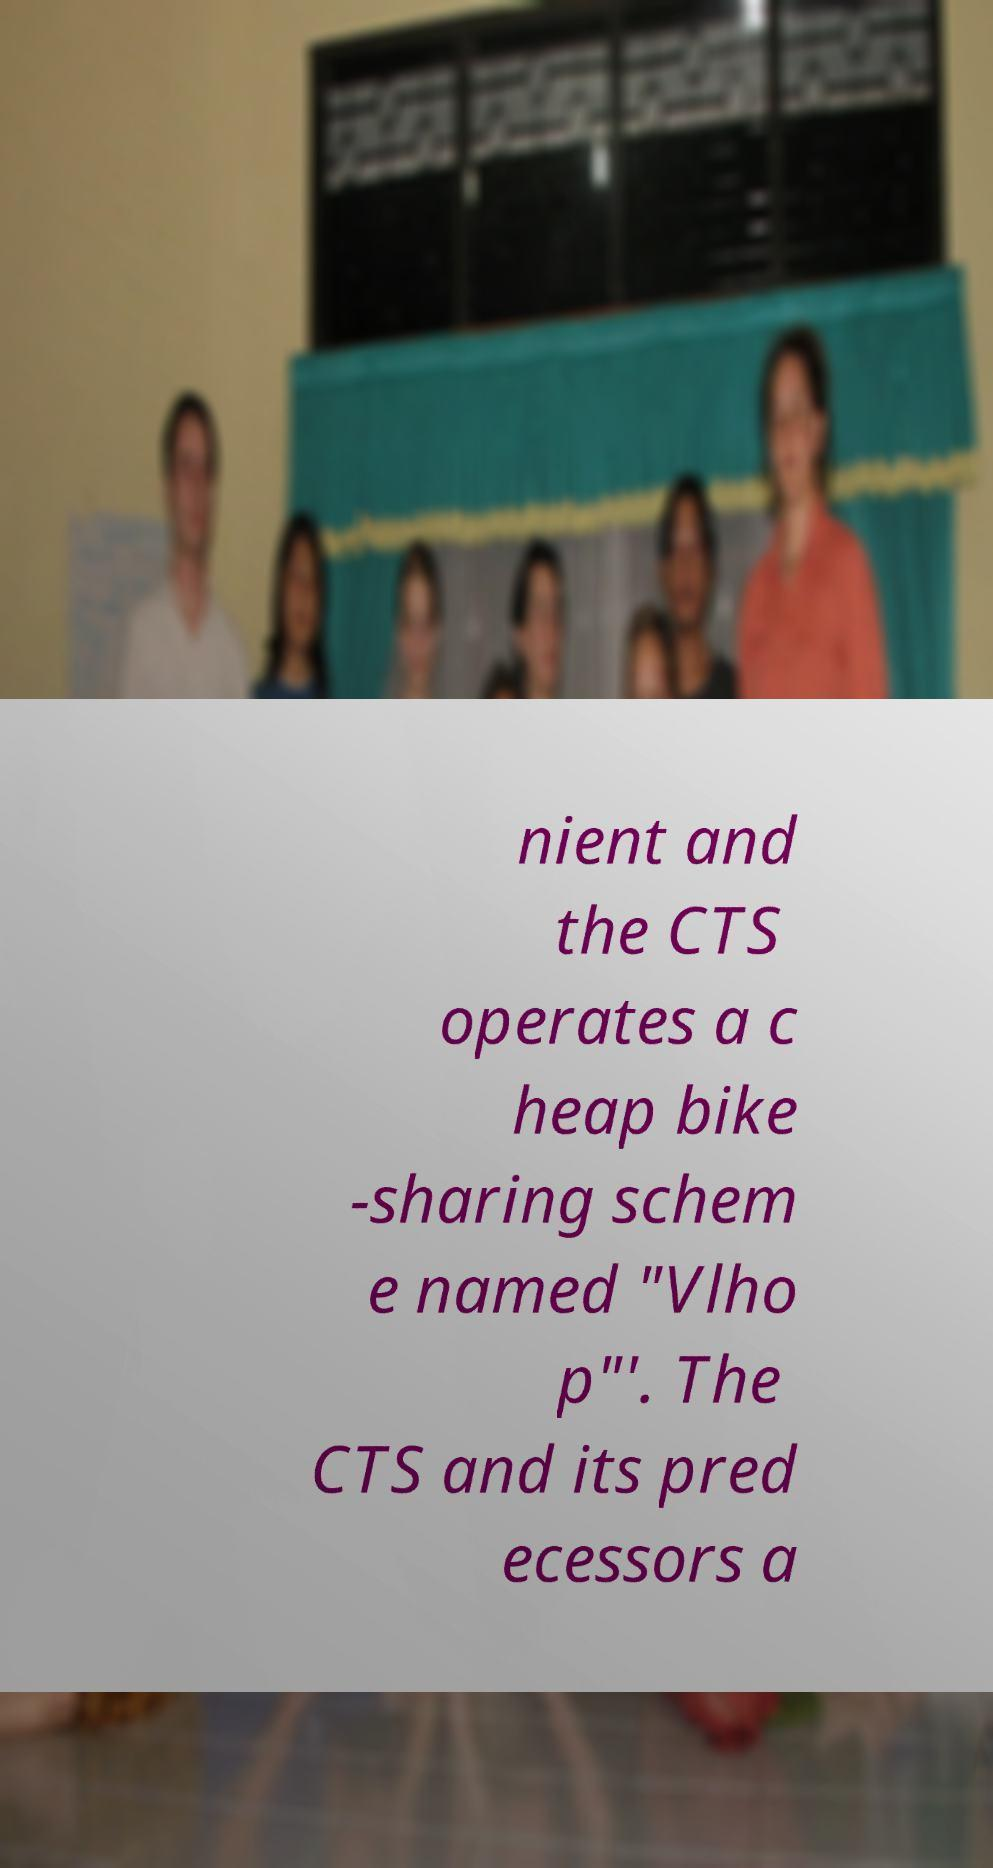For documentation purposes, I need the text within this image transcribed. Could you provide that? nient and the CTS operates a c heap bike -sharing schem e named "Vlho p"'. The CTS and its pred ecessors a 